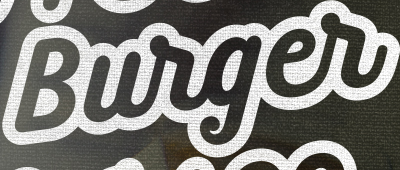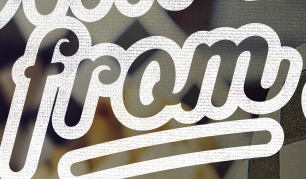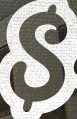What words are shown in these images in order, separated by a semicolon? Burger; from; $ 